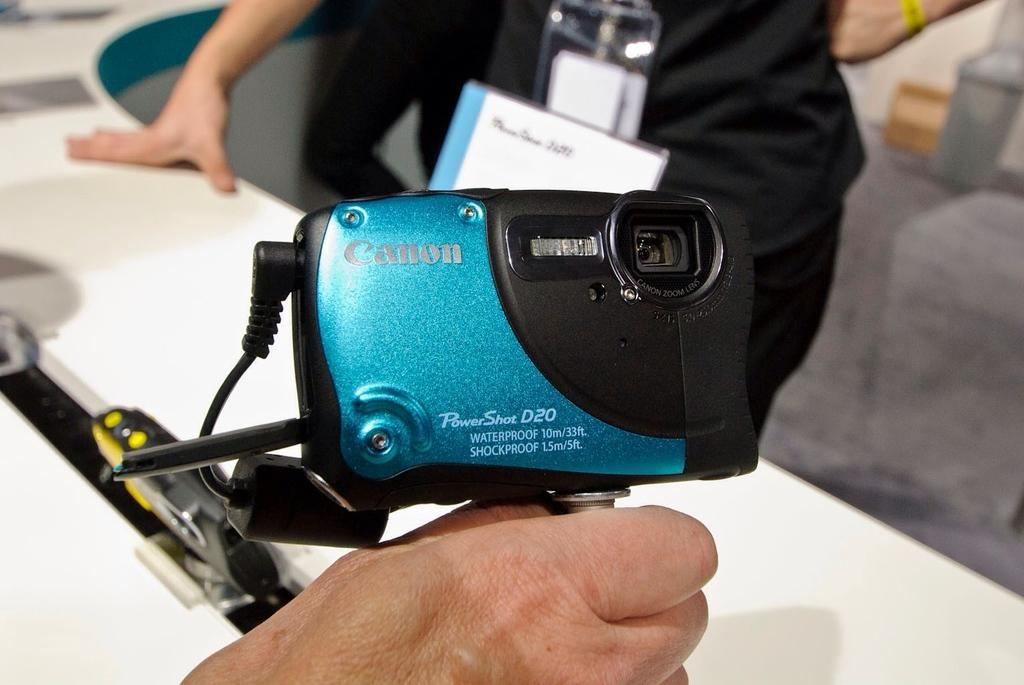What is the main subject of the image? There is a person holding a camera in the center of the image. What can be seen in the background of the image? There is a table, two persons, ID cards, and the floor visible in the background of the image. How many babies are sitting in the crate in the image? There is no crate or babies present in the image. What type of shock can be seen affecting the person holding the camera in the image? There is no shock or any indication of a shock in the image; the person is simply holding a camera. 